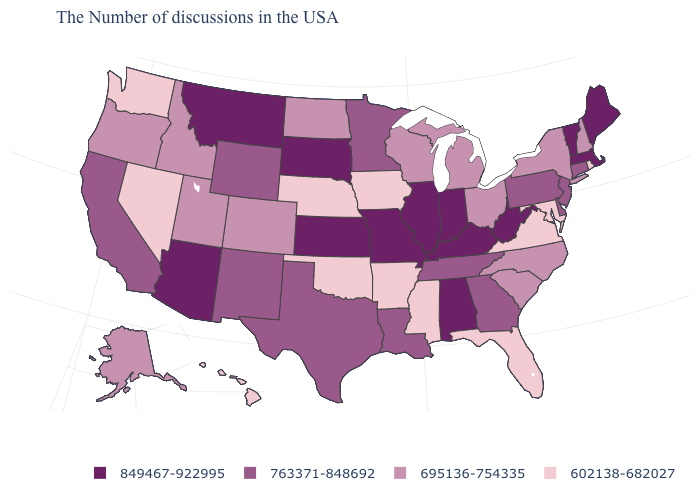Which states have the highest value in the USA?
Answer briefly. Maine, Massachusetts, Vermont, West Virginia, Kentucky, Indiana, Alabama, Illinois, Missouri, Kansas, South Dakota, Montana, Arizona. Which states have the lowest value in the USA?
Answer briefly. Rhode Island, Maryland, Virginia, Florida, Mississippi, Arkansas, Iowa, Nebraska, Oklahoma, Nevada, Washington, Hawaii. What is the value of Massachusetts?
Concise answer only. 849467-922995. Which states have the highest value in the USA?
Keep it brief. Maine, Massachusetts, Vermont, West Virginia, Kentucky, Indiana, Alabama, Illinois, Missouri, Kansas, South Dakota, Montana, Arizona. Name the states that have a value in the range 602138-682027?
Be succinct. Rhode Island, Maryland, Virginia, Florida, Mississippi, Arkansas, Iowa, Nebraska, Oklahoma, Nevada, Washington, Hawaii. Does Ohio have the lowest value in the MidWest?
Be succinct. No. Among the states that border Nevada , which have the highest value?
Concise answer only. Arizona. Does Wisconsin have the lowest value in the USA?
Quick response, please. No. Does the map have missing data?
Keep it brief. No. Among the states that border Indiana , does Michigan have the lowest value?
Write a very short answer. Yes. Name the states that have a value in the range 763371-848692?
Quick response, please. Connecticut, New Jersey, Delaware, Pennsylvania, Georgia, Tennessee, Louisiana, Minnesota, Texas, Wyoming, New Mexico, California. Does the first symbol in the legend represent the smallest category?
Answer briefly. No. Which states have the lowest value in the USA?
Be succinct. Rhode Island, Maryland, Virginia, Florida, Mississippi, Arkansas, Iowa, Nebraska, Oklahoma, Nevada, Washington, Hawaii. Is the legend a continuous bar?
Write a very short answer. No. 